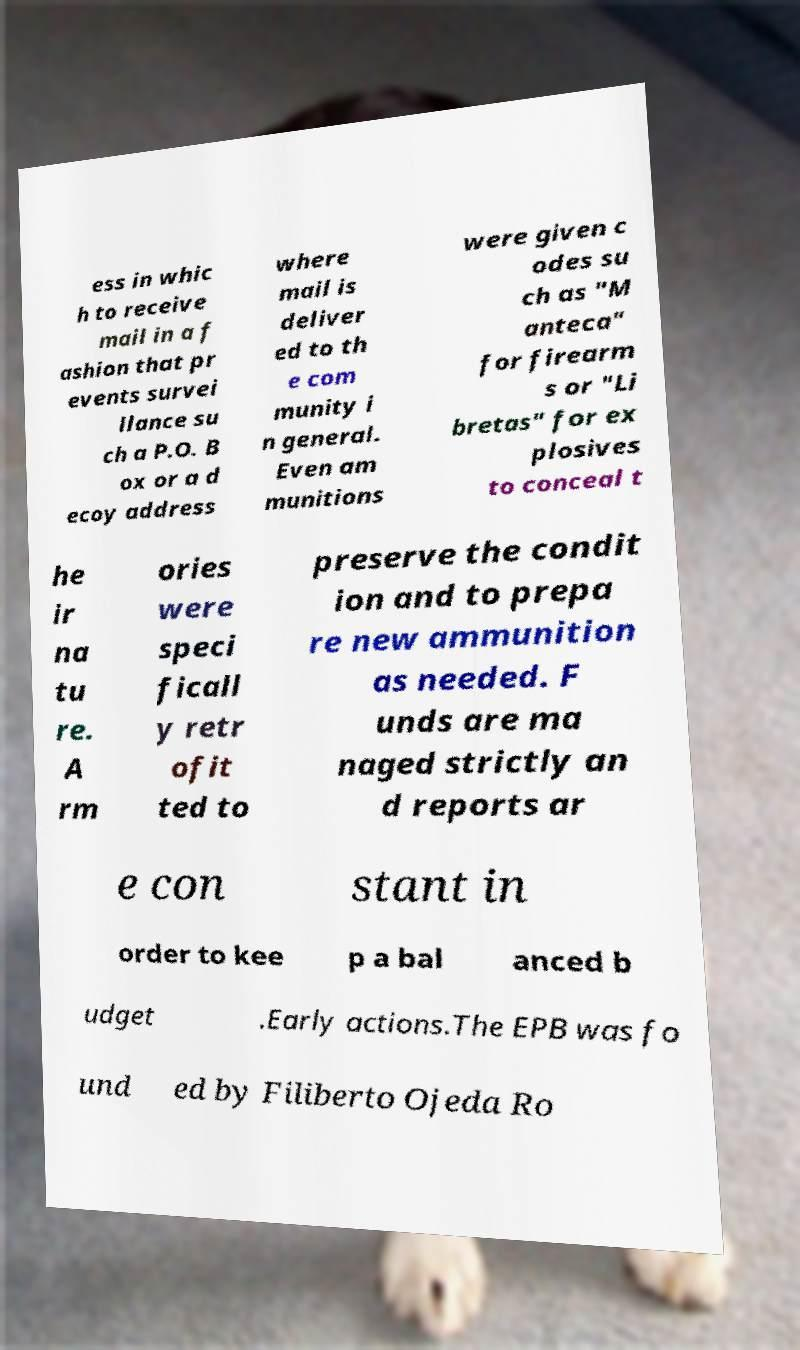Please identify and transcribe the text found in this image. ess in whic h to receive mail in a f ashion that pr events survei llance su ch a P.O. B ox or a d ecoy address where mail is deliver ed to th e com munity i n general. Even am munitions were given c odes su ch as "M anteca" for firearm s or "Li bretas" for ex plosives to conceal t he ir na tu re. A rm ories were speci ficall y retr ofit ted to preserve the condit ion and to prepa re new ammunition as needed. F unds are ma naged strictly an d reports ar e con stant in order to kee p a bal anced b udget .Early actions.The EPB was fo und ed by Filiberto Ojeda Ro 